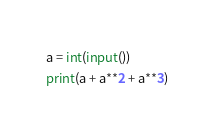Convert code to text. <code><loc_0><loc_0><loc_500><loc_500><_Python_>a = int(input())
print(a + a**2 + a**3)</code> 